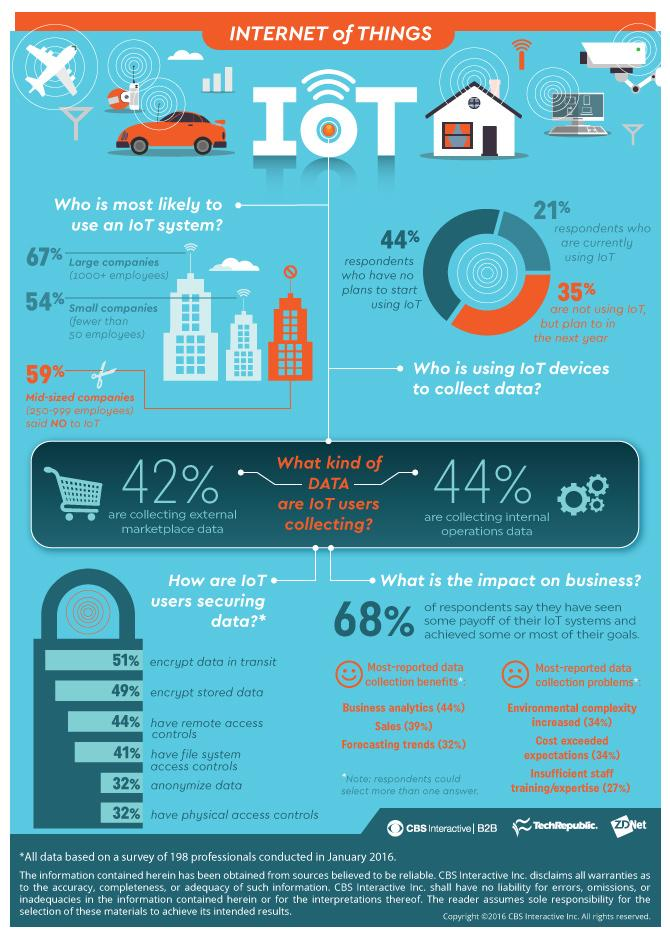Indicate a few pertinent items in this graphic. According to the survey, 44% of the participants have no interest in IoT. A total of 35% of the individuals who participated in the survey expressed an interest in the Internet of Things (IoT) and indicated their intent to incorporate it in the future. The color code used to represent the percentage of people not interested in IoT is orange. Encryption of stored data is the second method IoT users use to keep their data safe. According to a recent survey, only 21% of people are currently using the Internet of Things (IoT), with the remaining 79% not using it. 